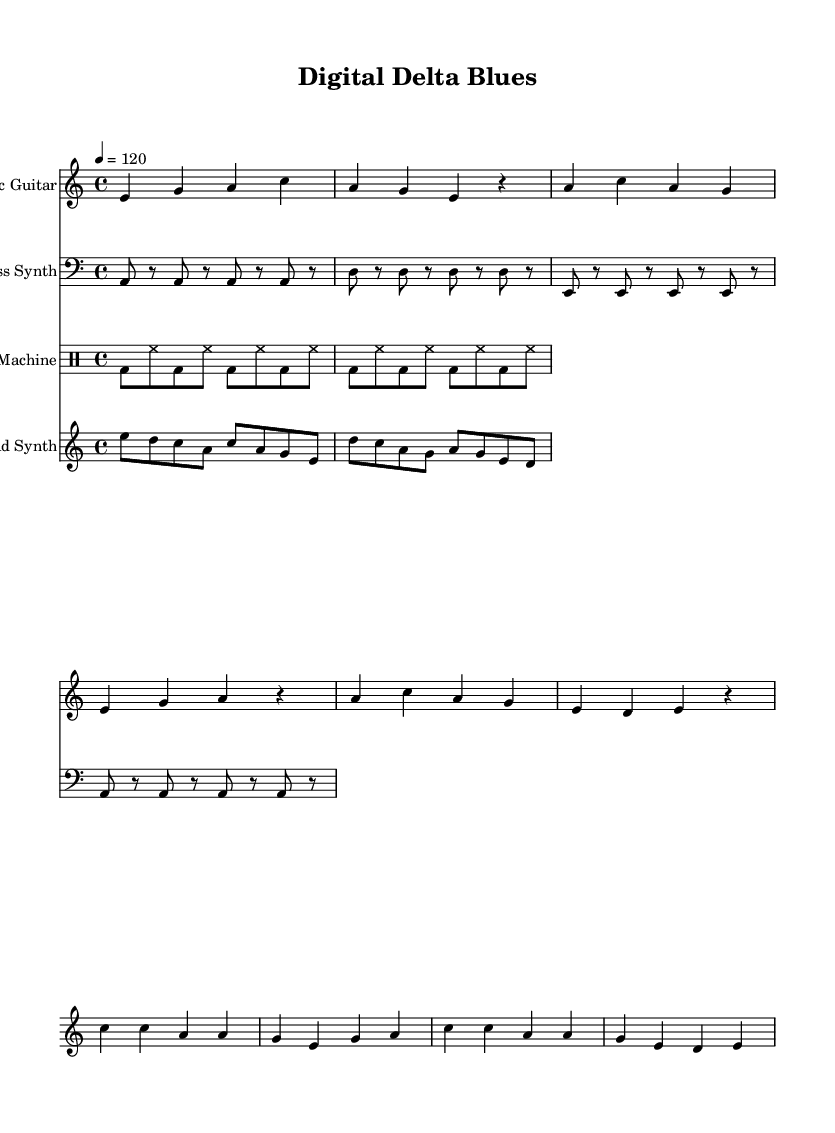What is the key signature of this music? The key signature is A minor, which is represented by no sharps or flats in the key signature. You can find the key signature at the beginning of the staff.
Answer: A minor What is the time signature of this music? The time signature is 4/4, indicated at the beginning of the score. It means there are four beats per measure, and the quarter note gets one beat.
Answer: 4/4 What is the tempo of the music? The tempo marking indicates that the piece is to be played at 120 beats per minute. This information is usually placed above the staff and gives the performer guidance on how fast to play.
Answer: 120 How many measures are there in the verse section? The verse section consists of three lines of music, with each line typically containing four measures, giving a total of 12 measures. By counting the measures in the verse section specifically, one arrives at this number.
Answer: 12 What instrument plays the lead melody in this piece? The lead melody is performed by the Lead Synth, which is specifically indicated in the score, along with the musical notes that outline the melody.
Answer: Lead Synth Which instrument is used for the percussive element? The Drum Machine is the instrument responsible for the rhythmic component in this composition, as seen in the drum patterns laid out in the drum staff section of the score.
Answer: Drum Machine What is the relationship between the verse and chorus in terms of chord progression? The verse utilizes a chord progression that returns to the tonic and mediant notes, while the chorus shifts the emphasis to a more climactic use of the tonic, subdominant, and dominant chords which are typical in blues music—comparing these sections shows the development and emphasis in structure.
Answer: Tonic, subdominant, dominant 